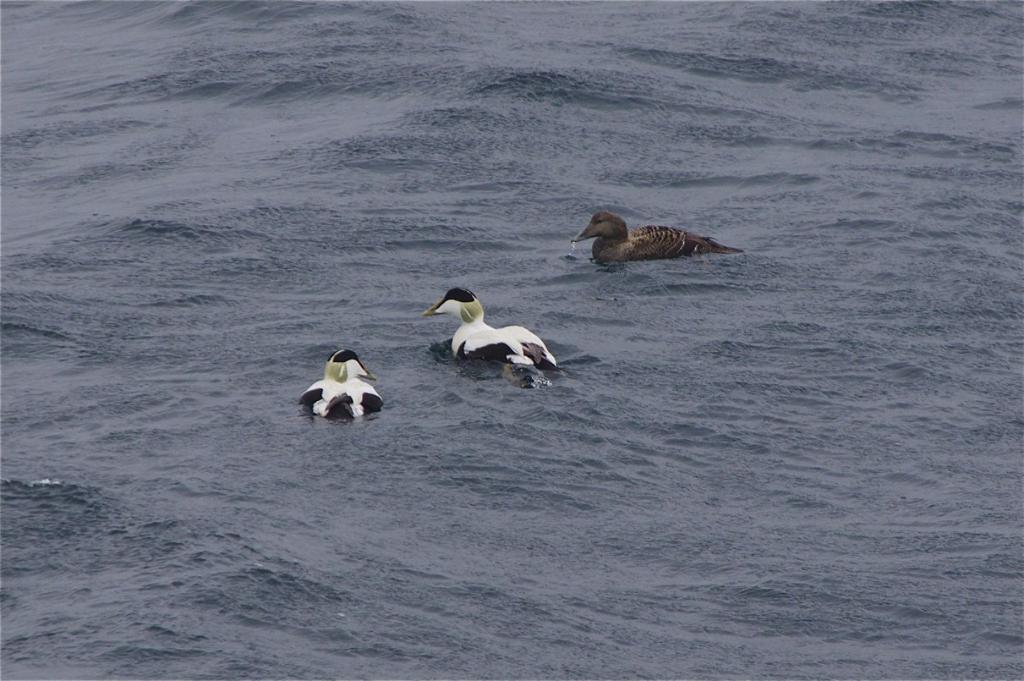Please provide a concise description of this image. In this image I can see few birds in the water and they are in brown, white and black color. 